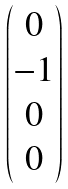Convert formula to latex. <formula><loc_0><loc_0><loc_500><loc_500>\begin{pmatrix} 0 \\ - 1 \\ 0 \\ 0 \end{pmatrix}</formula> 